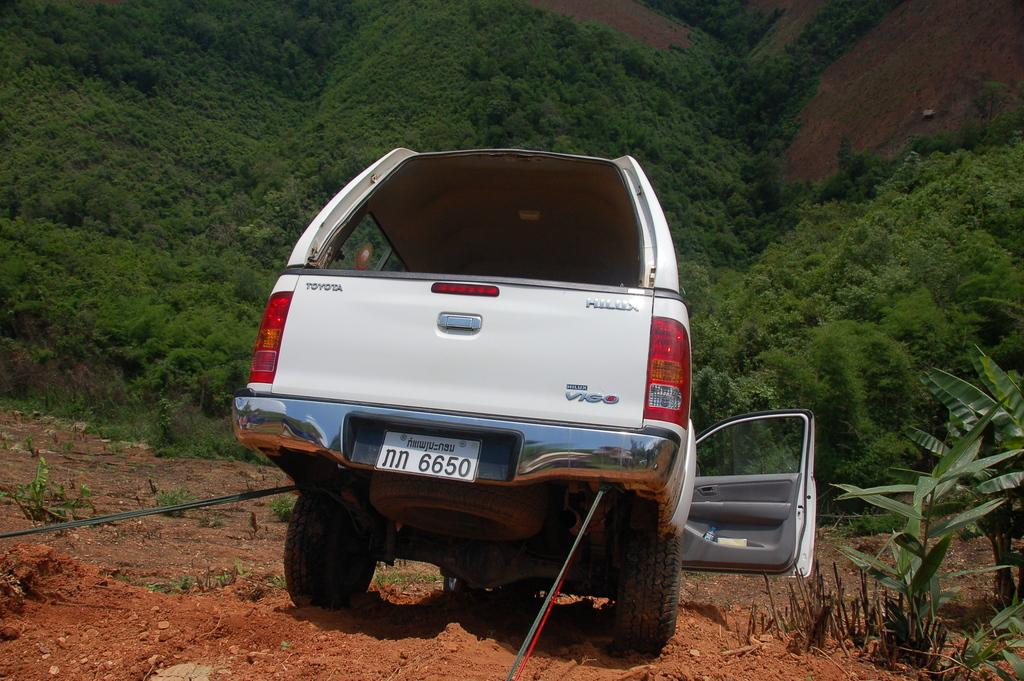What is connected to the car in the image? There are ropes tied to a car in the image. What else can be seen in the image besides the car and ropes? There are plants in the image. What is visible in the background of the image? There are trees in the background of the image. What type of meal is being prepared in the image? There is no meal preparation visible in the image; it only shows a car with ropes tied to it, plants, and trees in the background. 